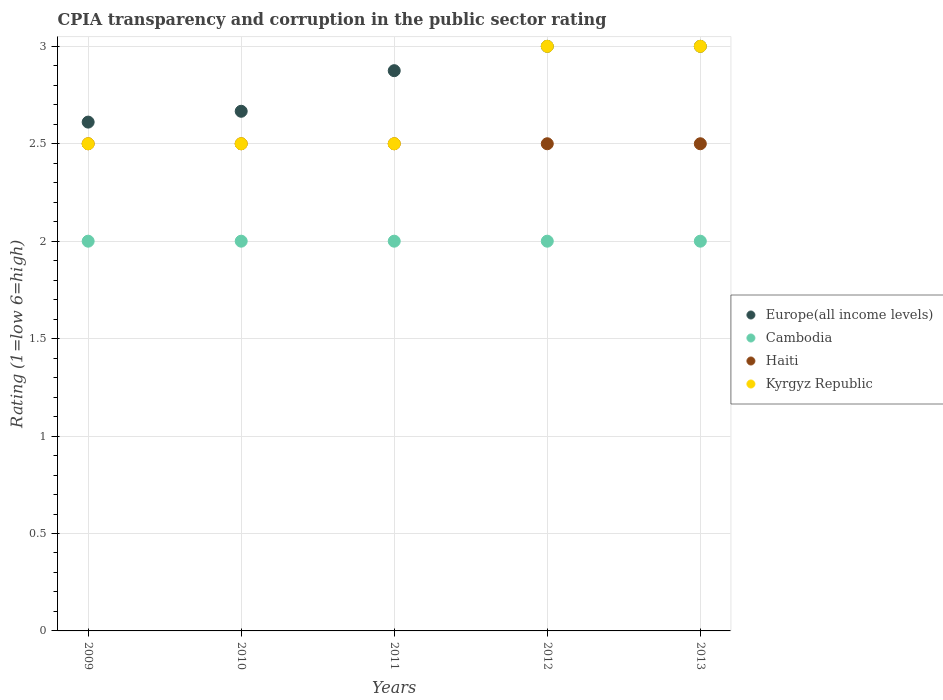How many different coloured dotlines are there?
Ensure brevity in your answer.  4. Is the number of dotlines equal to the number of legend labels?
Ensure brevity in your answer.  Yes. What is the CPIA rating in Kyrgyz Republic in 2009?
Provide a short and direct response. 2.5. Across all years, what is the maximum CPIA rating in Cambodia?
Make the answer very short. 2. Across all years, what is the minimum CPIA rating in Cambodia?
Give a very brief answer. 2. What is the total CPIA rating in Haiti in the graph?
Your answer should be very brief. 12.5. What is the difference between the CPIA rating in Europe(all income levels) in 2011 and that in 2013?
Make the answer very short. -0.12. What is the difference between the CPIA rating in Cambodia in 2011 and the CPIA rating in Kyrgyz Republic in 2012?
Your response must be concise. -1. What is the average CPIA rating in Haiti per year?
Keep it short and to the point. 2.5. In the year 2009, what is the difference between the CPIA rating in Europe(all income levels) and CPIA rating in Kyrgyz Republic?
Offer a terse response. 0.11. In how many years, is the CPIA rating in Cambodia greater than 1.4?
Your answer should be very brief. 5. What is the ratio of the CPIA rating in Europe(all income levels) in 2011 to that in 2012?
Your answer should be compact. 0.96. Is the difference between the CPIA rating in Europe(all income levels) in 2011 and 2013 greater than the difference between the CPIA rating in Kyrgyz Republic in 2011 and 2013?
Your answer should be compact. Yes. What is the difference between the highest and the second highest CPIA rating in Cambodia?
Give a very brief answer. 0. Is the sum of the CPIA rating in Kyrgyz Republic in 2009 and 2010 greater than the maximum CPIA rating in Cambodia across all years?
Offer a very short reply. Yes. Is it the case that in every year, the sum of the CPIA rating in Kyrgyz Republic and CPIA rating in Europe(all income levels)  is greater than the CPIA rating in Cambodia?
Provide a short and direct response. Yes. Does the CPIA rating in Cambodia monotonically increase over the years?
Your answer should be very brief. No. How many years are there in the graph?
Your answer should be very brief. 5. What is the difference between two consecutive major ticks on the Y-axis?
Offer a very short reply. 0.5. How are the legend labels stacked?
Keep it short and to the point. Vertical. What is the title of the graph?
Your answer should be very brief. CPIA transparency and corruption in the public sector rating. Does "Barbados" appear as one of the legend labels in the graph?
Give a very brief answer. No. What is the Rating (1=low 6=high) of Europe(all income levels) in 2009?
Make the answer very short. 2.61. What is the Rating (1=low 6=high) of Kyrgyz Republic in 2009?
Your response must be concise. 2.5. What is the Rating (1=low 6=high) of Europe(all income levels) in 2010?
Give a very brief answer. 2.67. What is the Rating (1=low 6=high) of Cambodia in 2010?
Keep it short and to the point. 2. What is the Rating (1=low 6=high) in Haiti in 2010?
Make the answer very short. 2.5. What is the Rating (1=low 6=high) in Kyrgyz Republic in 2010?
Provide a short and direct response. 2.5. What is the Rating (1=low 6=high) of Europe(all income levels) in 2011?
Your response must be concise. 2.88. What is the Rating (1=low 6=high) of Cambodia in 2011?
Offer a very short reply. 2. What is the Rating (1=low 6=high) in Cambodia in 2012?
Offer a very short reply. 2. What is the Rating (1=low 6=high) in Cambodia in 2013?
Your answer should be very brief. 2. What is the Rating (1=low 6=high) in Haiti in 2013?
Offer a very short reply. 2.5. What is the Rating (1=low 6=high) of Kyrgyz Republic in 2013?
Offer a terse response. 3. Across all years, what is the maximum Rating (1=low 6=high) in Europe(all income levels)?
Offer a very short reply. 3. Across all years, what is the maximum Rating (1=low 6=high) of Cambodia?
Your response must be concise. 2. Across all years, what is the minimum Rating (1=low 6=high) in Europe(all income levels)?
Provide a short and direct response. 2.61. Across all years, what is the minimum Rating (1=low 6=high) in Cambodia?
Make the answer very short. 2. Across all years, what is the minimum Rating (1=low 6=high) of Kyrgyz Republic?
Make the answer very short. 2.5. What is the total Rating (1=low 6=high) of Europe(all income levels) in the graph?
Your answer should be very brief. 14.15. What is the total Rating (1=low 6=high) of Cambodia in the graph?
Provide a short and direct response. 10. What is the difference between the Rating (1=low 6=high) in Europe(all income levels) in 2009 and that in 2010?
Your answer should be very brief. -0.06. What is the difference between the Rating (1=low 6=high) in Cambodia in 2009 and that in 2010?
Provide a succinct answer. 0. What is the difference between the Rating (1=low 6=high) of Haiti in 2009 and that in 2010?
Provide a succinct answer. 0. What is the difference between the Rating (1=low 6=high) in Kyrgyz Republic in 2009 and that in 2010?
Offer a terse response. 0. What is the difference between the Rating (1=low 6=high) in Europe(all income levels) in 2009 and that in 2011?
Ensure brevity in your answer.  -0.26. What is the difference between the Rating (1=low 6=high) in Cambodia in 2009 and that in 2011?
Make the answer very short. 0. What is the difference between the Rating (1=low 6=high) of Haiti in 2009 and that in 2011?
Give a very brief answer. 0. What is the difference between the Rating (1=low 6=high) of Europe(all income levels) in 2009 and that in 2012?
Provide a short and direct response. -0.39. What is the difference between the Rating (1=low 6=high) in Cambodia in 2009 and that in 2012?
Offer a very short reply. 0. What is the difference between the Rating (1=low 6=high) of Kyrgyz Republic in 2009 and that in 2012?
Your answer should be very brief. -0.5. What is the difference between the Rating (1=low 6=high) in Europe(all income levels) in 2009 and that in 2013?
Keep it short and to the point. -0.39. What is the difference between the Rating (1=low 6=high) in Cambodia in 2009 and that in 2013?
Keep it short and to the point. 0. What is the difference between the Rating (1=low 6=high) of Europe(all income levels) in 2010 and that in 2011?
Offer a very short reply. -0.21. What is the difference between the Rating (1=low 6=high) of Haiti in 2010 and that in 2011?
Provide a short and direct response. 0. What is the difference between the Rating (1=low 6=high) in Kyrgyz Republic in 2010 and that in 2011?
Keep it short and to the point. 0. What is the difference between the Rating (1=low 6=high) in Cambodia in 2010 and that in 2012?
Your answer should be very brief. 0. What is the difference between the Rating (1=low 6=high) of Haiti in 2010 and that in 2013?
Your answer should be very brief. 0. What is the difference between the Rating (1=low 6=high) of Kyrgyz Republic in 2010 and that in 2013?
Your answer should be very brief. -0.5. What is the difference between the Rating (1=low 6=high) in Europe(all income levels) in 2011 and that in 2012?
Ensure brevity in your answer.  -0.12. What is the difference between the Rating (1=low 6=high) of Cambodia in 2011 and that in 2012?
Your answer should be compact. 0. What is the difference between the Rating (1=low 6=high) of Kyrgyz Republic in 2011 and that in 2012?
Provide a succinct answer. -0.5. What is the difference between the Rating (1=low 6=high) in Europe(all income levels) in 2011 and that in 2013?
Provide a succinct answer. -0.12. What is the difference between the Rating (1=low 6=high) of Cambodia in 2011 and that in 2013?
Provide a succinct answer. 0. What is the difference between the Rating (1=low 6=high) in Cambodia in 2012 and that in 2013?
Your answer should be compact. 0. What is the difference between the Rating (1=low 6=high) in Haiti in 2012 and that in 2013?
Provide a short and direct response. 0. What is the difference between the Rating (1=low 6=high) of Kyrgyz Republic in 2012 and that in 2013?
Provide a succinct answer. 0. What is the difference between the Rating (1=low 6=high) in Europe(all income levels) in 2009 and the Rating (1=low 6=high) in Cambodia in 2010?
Offer a terse response. 0.61. What is the difference between the Rating (1=low 6=high) of Europe(all income levels) in 2009 and the Rating (1=low 6=high) of Haiti in 2010?
Give a very brief answer. 0.11. What is the difference between the Rating (1=low 6=high) in Europe(all income levels) in 2009 and the Rating (1=low 6=high) in Kyrgyz Republic in 2010?
Offer a very short reply. 0.11. What is the difference between the Rating (1=low 6=high) of Cambodia in 2009 and the Rating (1=low 6=high) of Haiti in 2010?
Your response must be concise. -0.5. What is the difference between the Rating (1=low 6=high) in Haiti in 2009 and the Rating (1=low 6=high) in Kyrgyz Republic in 2010?
Offer a terse response. 0. What is the difference between the Rating (1=low 6=high) in Europe(all income levels) in 2009 and the Rating (1=low 6=high) in Cambodia in 2011?
Make the answer very short. 0.61. What is the difference between the Rating (1=low 6=high) of Europe(all income levels) in 2009 and the Rating (1=low 6=high) of Haiti in 2011?
Give a very brief answer. 0.11. What is the difference between the Rating (1=low 6=high) of Europe(all income levels) in 2009 and the Rating (1=low 6=high) of Kyrgyz Republic in 2011?
Provide a succinct answer. 0.11. What is the difference between the Rating (1=low 6=high) of Europe(all income levels) in 2009 and the Rating (1=low 6=high) of Cambodia in 2012?
Your answer should be compact. 0.61. What is the difference between the Rating (1=low 6=high) of Europe(all income levels) in 2009 and the Rating (1=low 6=high) of Haiti in 2012?
Give a very brief answer. 0.11. What is the difference between the Rating (1=low 6=high) in Europe(all income levels) in 2009 and the Rating (1=low 6=high) in Kyrgyz Republic in 2012?
Your answer should be compact. -0.39. What is the difference between the Rating (1=low 6=high) in Cambodia in 2009 and the Rating (1=low 6=high) in Haiti in 2012?
Offer a very short reply. -0.5. What is the difference between the Rating (1=low 6=high) of Europe(all income levels) in 2009 and the Rating (1=low 6=high) of Cambodia in 2013?
Your response must be concise. 0.61. What is the difference between the Rating (1=low 6=high) of Europe(all income levels) in 2009 and the Rating (1=low 6=high) of Kyrgyz Republic in 2013?
Offer a very short reply. -0.39. What is the difference between the Rating (1=low 6=high) in Cambodia in 2009 and the Rating (1=low 6=high) in Haiti in 2013?
Your response must be concise. -0.5. What is the difference between the Rating (1=low 6=high) of Cambodia in 2009 and the Rating (1=low 6=high) of Kyrgyz Republic in 2013?
Your answer should be compact. -1. What is the difference between the Rating (1=low 6=high) in Europe(all income levels) in 2010 and the Rating (1=low 6=high) in Cambodia in 2011?
Provide a short and direct response. 0.67. What is the difference between the Rating (1=low 6=high) in Europe(all income levels) in 2010 and the Rating (1=low 6=high) in Kyrgyz Republic in 2011?
Ensure brevity in your answer.  0.17. What is the difference between the Rating (1=low 6=high) of Cambodia in 2010 and the Rating (1=low 6=high) of Haiti in 2011?
Provide a succinct answer. -0.5. What is the difference between the Rating (1=low 6=high) in Cambodia in 2010 and the Rating (1=low 6=high) in Kyrgyz Republic in 2011?
Your response must be concise. -0.5. What is the difference between the Rating (1=low 6=high) in Europe(all income levels) in 2010 and the Rating (1=low 6=high) in Kyrgyz Republic in 2012?
Give a very brief answer. -0.33. What is the difference between the Rating (1=low 6=high) of Europe(all income levels) in 2010 and the Rating (1=low 6=high) of Haiti in 2013?
Offer a very short reply. 0.17. What is the difference between the Rating (1=low 6=high) in Europe(all income levels) in 2010 and the Rating (1=low 6=high) in Kyrgyz Republic in 2013?
Provide a succinct answer. -0.33. What is the difference between the Rating (1=low 6=high) of Cambodia in 2010 and the Rating (1=low 6=high) of Haiti in 2013?
Make the answer very short. -0.5. What is the difference between the Rating (1=low 6=high) of Haiti in 2010 and the Rating (1=low 6=high) of Kyrgyz Republic in 2013?
Your answer should be compact. -0.5. What is the difference between the Rating (1=low 6=high) of Europe(all income levels) in 2011 and the Rating (1=low 6=high) of Cambodia in 2012?
Make the answer very short. 0.88. What is the difference between the Rating (1=low 6=high) in Europe(all income levels) in 2011 and the Rating (1=low 6=high) in Haiti in 2012?
Ensure brevity in your answer.  0.38. What is the difference between the Rating (1=low 6=high) of Europe(all income levels) in 2011 and the Rating (1=low 6=high) of Kyrgyz Republic in 2012?
Offer a very short reply. -0.12. What is the difference between the Rating (1=low 6=high) in Cambodia in 2011 and the Rating (1=low 6=high) in Haiti in 2012?
Your answer should be very brief. -0.5. What is the difference between the Rating (1=low 6=high) of Cambodia in 2011 and the Rating (1=low 6=high) of Kyrgyz Republic in 2012?
Give a very brief answer. -1. What is the difference between the Rating (1=low 6=high) in Europe(all income levels) in 2011 and the Rating (1=low 6=high) in Cambodia in 2013?
Offer a terse response. 0.88. What is the difference between the Rating (1=low 6=high) in Europe(all income levels) in 2011 and the Rating (1=low 6=high) in Kyrgyz Republic in 2013?
Your answer should be very brief. -0.12. What is the difference between the Rating (1=low 6=high) in Cambodia in 2011 and the Rating (1=low 6=high) in Haiti in 2013?
Offer a very short reply. -0.5. What is the difference between the Rating (1=low 6=high) of Cambodia in 2011 and the Rating (1=low 6=high) of Kyrgyz Republic in 2013?
Make the answer very short. -1. What is the difference between the Rating (1=low 6=high) in Haiti in 2011 and the Rating (1=low 6=high) in Kyrgyz Republic in 2013?
Offer a very short reply. -0.5. What is the difference between the Rating (1=low 6=high) of Europe(all income levels) in 2012 and the Rating (1=low 6=high) of Haiti in 2013?
Offer a very short reply. 0.5. What is the difference between the Rating (1=low 6=high) in Europe(all income levels) in 2012 and the Rating (1=low 6=high) in Kyrgyz Republic in 2013?
Make the answer very short. 0. What is the difference between the Rating (1=low 6=high) of Cambodia in 2012 and the Rating (1=low 6=high) of Haiti in 2013?
Ensure brevity in your answer.  -0.5. What is the difference between the Rating (1=low 6=high) in Haiti in 2012 and the Rating (1=low 6=high) in Kyrgyz Republic in 2013?
Provide a succinct answer. -0.5. What is the average Rating (1=low 6=high) in Europe(all income levels) per year?
Your response must be concise. 2.83. What is the average Rating (1=low 6=high) in Cambodia per year?
Your response must be concise. 2. In the year 2009, what is the difference between the Rating (1=low 6=high) in Europe(all income levels) and Rating (1=low 6=high) in Cambodia?
Offer a very short reply. 0.61. In the year 2009, what is the difference between the Rating (1=low 6=high) of Europe(all income levels) and Rating (1=low 6=high) of Haiti?
Ensure brevity in your answer.  0.11. In the year 2009, what is the difference between the Rating (1=low 6=high) in Cambodia and Rating (1=low 6=high) in Haiti?
Keep it short and to the point. -0.5. In the year 2009, what is the difference between the Rating (1=low 6=high) of Haiti and Rating (1=low 6=high) of Kyrgyz Republic?
Your response must be concise. 0. In the year 2010, what is the difference between the Rating (1=low 6=high) of Europe(all income levels) and Rating (1=low 6=high) of Kyrgyz Republic?
Your answer should be very brief. 0.17. In the year 2010, what is the difference between the Rating (1=low 6=high) in Cambodia and Rating (1=low 6=high) in Haiti?
Offer a terse response. -0.5. In the year 2010, what is the difference between the Rating (1=low 6=high) of Cambodia and Rating (1=low 6=high) of Kyrgyz Republic?
Ensure brevity in your answer.  -0.5. In the year 2010, what is the difference between the Rating (1=low 6=high) of Haiti and Rating (1=low 6=high) of Kyrgyz Republic?
Offer a very short reply. 0. In the year 2011, what is the difference between the Rating (1=low 6=high) in Europe(all income levels) and Rating (1=low 6=high) in Cambodia?
Give a very brief answer. 0.88. In the year 2011, what is the difference between the Rating (1=low 6=high) in Europe(all income levels) and Rating (1=low 6=high) in Kyrgyz Republic?
Offer a very short reply. 0.38. In the year 2011, what is the difference between the Rating (1=low 6=high) in Cambodia and Rating (1=low 6=high) in Haiti?
Ensure brevity in your answer.  -0.5. In the year 2011, what is the difference between the Rating (1=low 6=high) of Cambodia and Rating (1=low 6=high) of Kyrgyz Republic?
Give a very brief answer. -0.5. In the year 2012, what is the difference between the Rating (1=low 6=high) in Europe(all income levels) and Rating (1=low 6=high) in Haiti?
Ensure brevity in your answer.  0.5. In the year 2012, what is the difference between the Rating (1=low 6=high) of Europe(all income levels) and Rating (1=low 6=high) of Kyrgyz Republic?
Offer a terse response. 0. In the year 2012, what is the difference between the Rating (1=low 6=high) in Cambodia and Rating (1=low 6=high) in Kyrgyz Republic?
Give a very brief answer. -1. In the year 2013, what is the difference between the Rating (1=low 6=high) in Cambodia and Rating (1=low 6=high) in Haiti?
Provide a succinct answer. -0.5. In the year 2013, what is the difference between the Rating (1=low 6=high) of Cambodia and Rating (1=low 6=high) of Kyrgyz Republic?
Your response must be concise. -1. In the year 2013, what is the difference between the Rating (1=low 6=high) in Haiti and Rating (1=low 6=high) in Kyrgyz Republic?
Your answer should be very brief. -0.5. What is the ratio of the Rating (1=low 6=high) of Europe(all income levels) in 2009 to that in 2010?
Your response must be concise. 0.98. What is the ratio of the Rating (1=low 6=high) in Cambodia in 2009 to that in 2010?
Make the answer very short. 1. What is the ratio of the Rating (1=low 6=high) of Europe(all income levels) in 2009 to that in 2011?
Your response must be concise. 0.91. What is the ratio of the Rating (1=low 6=high) in Cambodia in 2009 to that in 2011?
Your answer should be compact. 1. What is the ratio of the Rating (1=low 6=high) of Haiti in 2009 to that in 2011?
Make the answer very short. 1. What is the ratio of the Rating (1=low 6=high) in Kyrgyz Republic in 2009 to that in 2011?
Provide a short and direct response. 1. What is the ratio of the Rating (1=low 6=high) in Europe(all income levels) in 2009 to that in 2012?
Your answer should be very brief. 0.87. What is the ratio of the Rating (1=low 6=high) of Cambodia in 2009 to that in 2012?
Offer a very short reply. 1. What is the ratio of the Rating (1=low 6=high) of Kyrgyz Republic in 2009 to that in 2012?
Your answer should be compact. 0.83. What is the ratio of the Rating (1=low 6=high) in Europe(all income levels) in 2009 to that in 2013?
Your answer should be very brief. 0.87. What is the ratio of the Rating (1=low 6=high) in Cambodia in 2009 to that in 2013?
Offer a very short reply. 1. What is the ratio of the Rating (1=low 6=high) of Kyrgyz Republic in 2009 to that in 2013?
Offer a very short reply. 0.83. What is the ratio of the Rating (1=low 6=high) in Europe(all income levels) in 2010 to that in 2011?
Your answer should be very brief. 0.93. What is the ratio of the Rating (1=low 6=high) of Cambodia in 2010 to that in 2011?
Provide a succinct answer. 1. What is the ratio of the Rating (1=low 6=high) of Kyrgyz Republic in 2010 to that in 2011?
Give a very brief answer. 1. What is the ratio of the Rating (1=low 6=high) in Europe(all income levels) in 2010 to that in 2012?
Your answer should be very brief. 0.89. What is the ratio of the Rating (1=low 6=high) in Haiti in 2010 to that in 2012?
Provide a short and direct response. 1. What is the ratio of the Rating (1=low 6=high) in Europe(all income levels) in 2010 to that in 2013?
Keep it short and to the point. 0.89. What is the ratio of the Rating (1=low 6=high) of Kyrgyz Republic in 2010 to that in 2013?
Keep it short and to the point. 0.83. What is the ratio of the Rating (1=low 6=high) of Kyrgyz Republic in 2011 to that in 2012?
Make the answer very short. 0.83. What is the ratio of the Rating (1=low 6=high) in Kyrgyz Republic in 2011 to that in 2013?
Provide a short and direct response. 0.83. What is the ratio of the Rating (1=low 6=high) of Cambodia in 2012 to that in 2013?
Provide a succinct answer. 1. What is the difference between the highest and the second highest Rating (1=low 6=high) of Europe(all income levels)?
Give a very brief answer. 0. What is the difference between the highest and the second highest Rating (1=low 6=high) in Cambodia?
Your response must be concise. 0. What is the difference between the highest and the lowest Rating (1=low 6=high) in Europe(all income levels)?
Make the answer very short. 0.39. 